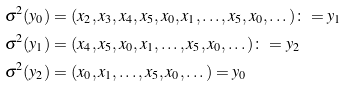<formula> <loc_0><loc_0><loc_500><loc_500>& \sigma ^ { 2 } ( y _ { 0 } ) = ( x _ { 2 } , x _ { 3 } , x _ { 4 } , x _ { 5 } , x _ { 0 } , x _ { 1 } , \dots , x _ { 5 } , x _ { 0 } , \dots ) \colon = y _ { 1 } \\ & \sigma ^ { 2 } ( y _ { 1 } ) = ( x _ { 4 } , x _ { 5 } , x _ { 0 } , x _ { 1 } , \dots , x _ { 5 } , x _ { 0 } , \dots ) \colon = y _ { 2 } \\ & \sigma ^ { 2 } ( y _ { 2 } ) = ( x _ { 0 } , x _ { 1 } , \dots , x _ { 5 } , x _ { 0 } , \dots ) = y _ { 0 }</formula> 